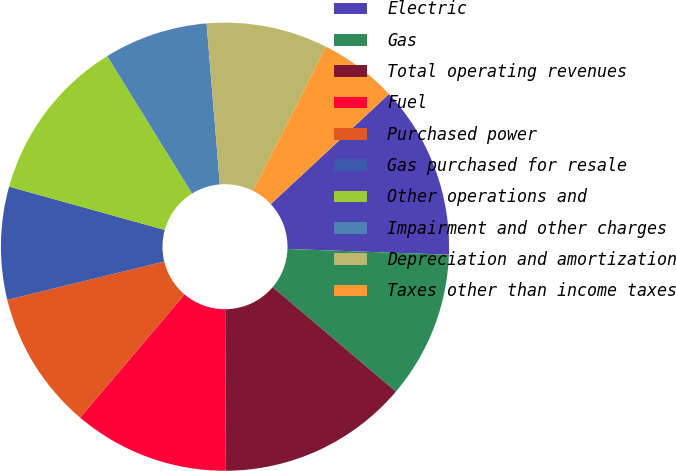Convert chart. <chart><loc_0><loc_0><loc_500><loc_500><pie_chart><fcel>Electric<fcel>Gas<fcel>Total operating revenues<fcel>Fuel<fcel>Purchased power<fcel>Gas purchased for resale<fcel>Other operations and<fcel>Impairment and other charges<fcel>Depreciation and amortization<fcel>Taxes other than income taxes<nl><fcel>12.5%<fcel>10.62%<fcel>13.75%<fcel>11.25%<fcel>10.0%<fcel>8.13%<fcel>11.87%<fcel>7.5%<fcel>8.75%<fcel>5.63%<nl></chart> 